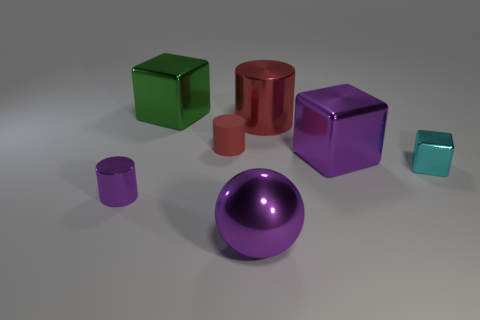Can you describe the shapes and their colors in the image? Certainly! There are six objects with distinct shapes and colors. If we go from left to right, we first see a small green cube, then a large red cylinder, followed by a big purple cube. In the front, there's a small purple cylinder, and beside it is a large pink cylinder that's shorter in height. Finally, on the far right, there's a small teal cube. In the center of these objects is a shiny deep purple ball. 